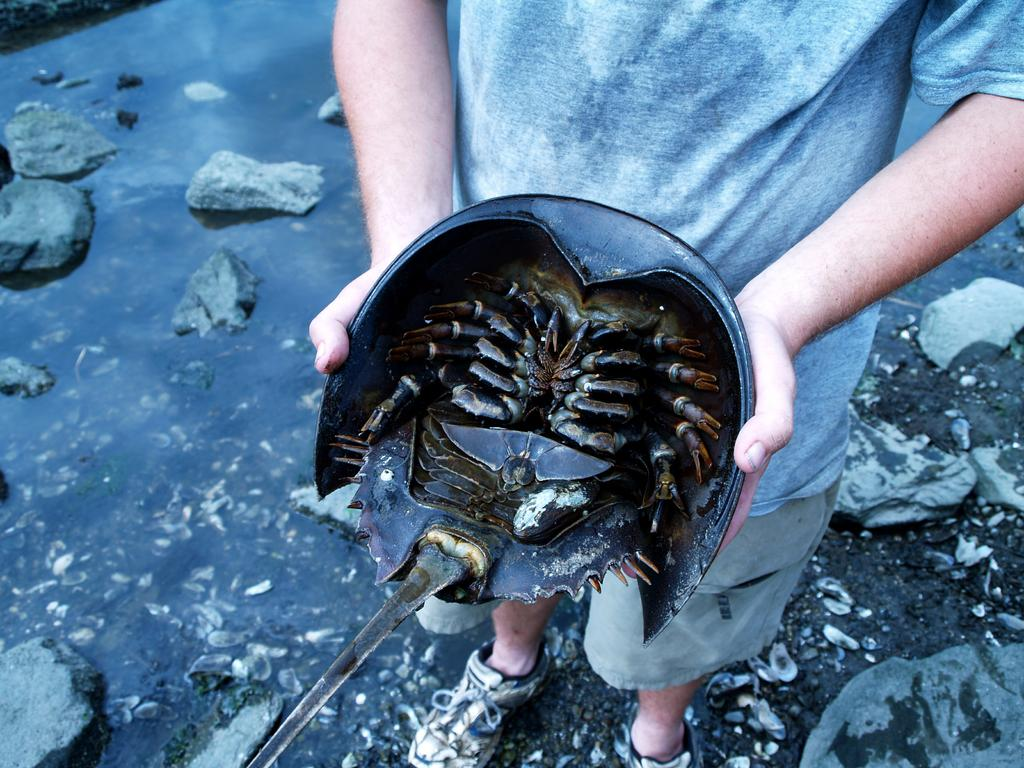Who is present in the image? There is a person in the image. What is the person holding in the image? The person is holding a container. What is inside the container? The container contains a crab. What is visible in the background of the image? There is water visible in the image. What type of terrain is at the bottom of the image? Rocks are present at the bottom of the image. What type of roof can be seen in the image? There is no roof present in the image. Can you describe the cellar in the image? There is no cellar present in the image. 